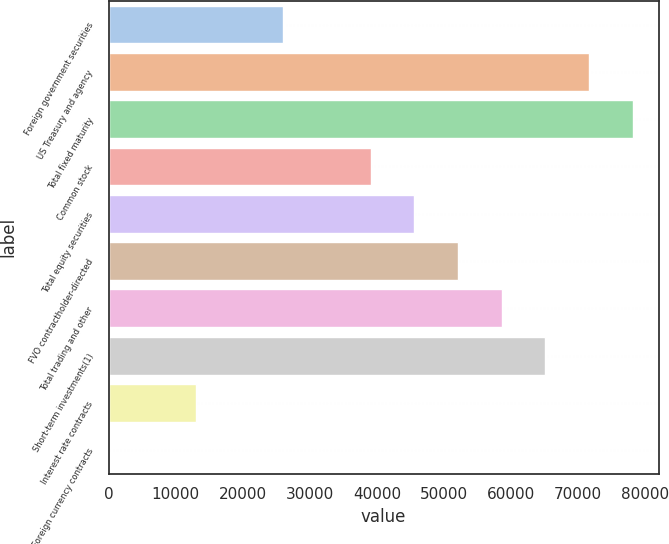<chart> <loc_0><loc_0><loc_500><loc_500><bar_chart><fcel>Foreign government securities<fcel>US Treasury and agency<fcel>Total fixed maturity<fcel>Common stock<fcel>Total equity securities<fcel>FVO contractholder-directed<fcel>Total trading and other<fcel>Short-term investments(1)<fcel>Interest rate contracts<fcel>Foreign currency contracts<nl><fcel>26037.8<fcel>71602.2<fcel>78111.4<fcel>39056.2<fcel>45565.4<fcel>52074.6<fcel>58583.8<fcel>65093<fcel>13019.4<fcel>1<nl></chart> 